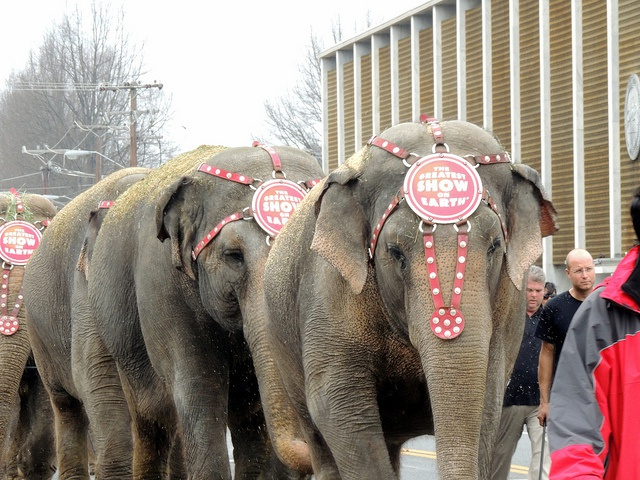Describe the objects in this image and their specific colors. I can see elephant in white, gray, darkgray, and black tones, elephant in white, gray, black, and darkgray tones, people in white, red, and gray tones, elephant in white, black, gray, and lightpink tones, and people in white, black, gray, darkgray, and lightgray tones in this image. 